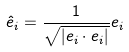<formula> <loc_0><loc_0><loc_500><loc_500>\hat { e } _ { i } = \frac { 1 } { \sqrt { | e _ { i } \cdot e _ { i } | } } e _ { i }</formula> 